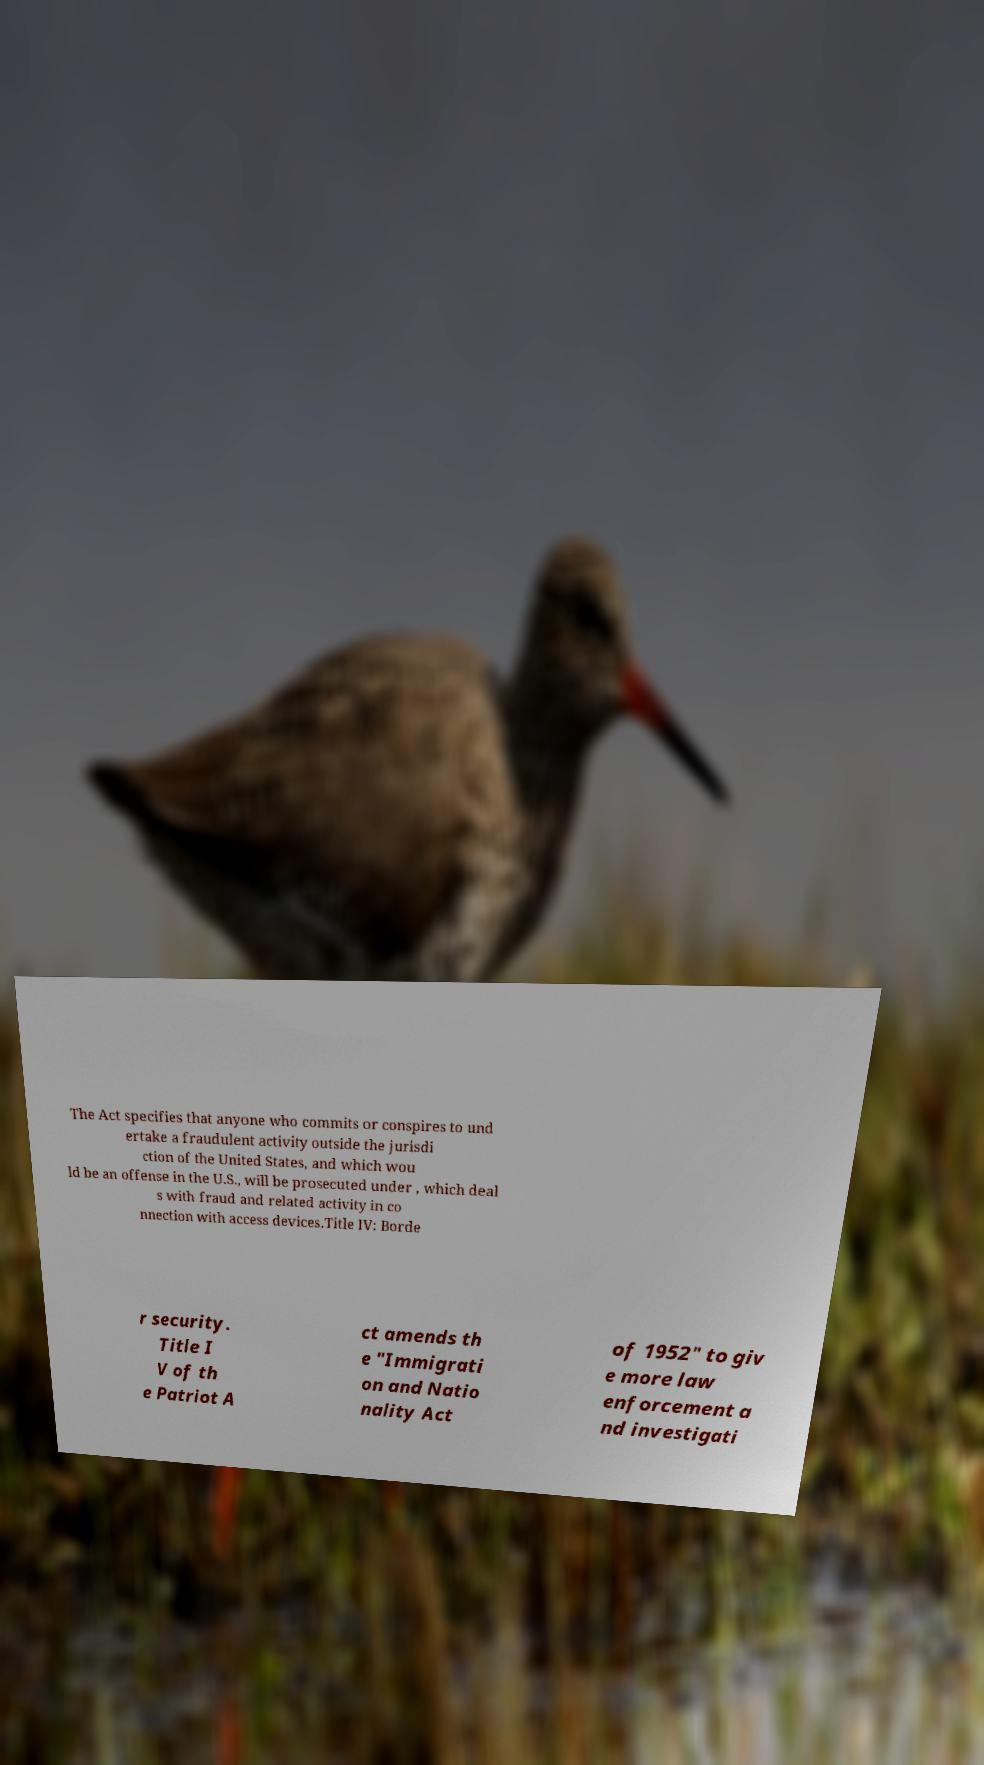There's text embedded in this image that I need extracted. Can you transcribe it verbatim? The Act specifies that anyone who commits or conspires to und ertake a fraudulent activity outside the jurisdi ction of the United States, and which wou ld be an offense in the U.S., will be prosecuted under , which deal s with fraud and related activity in co nnection with access devices.Title IV: Borde r security. Title I V of th e Patriot A ct amends th e "Immigrati on and Natio nality Act of 1952" to giv e more law enforcement a nd investigati 